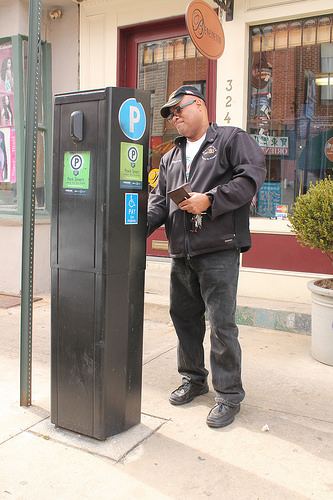<image>
Can you confirm if the sign is on the man? No. The sign is not positioned on the man. They may be near each other, but the sign is not supported by or resting on top of the man. Is the ground next to the sign? No. The ground is not positioned next to the sign. They are located in different areas of the scene. 